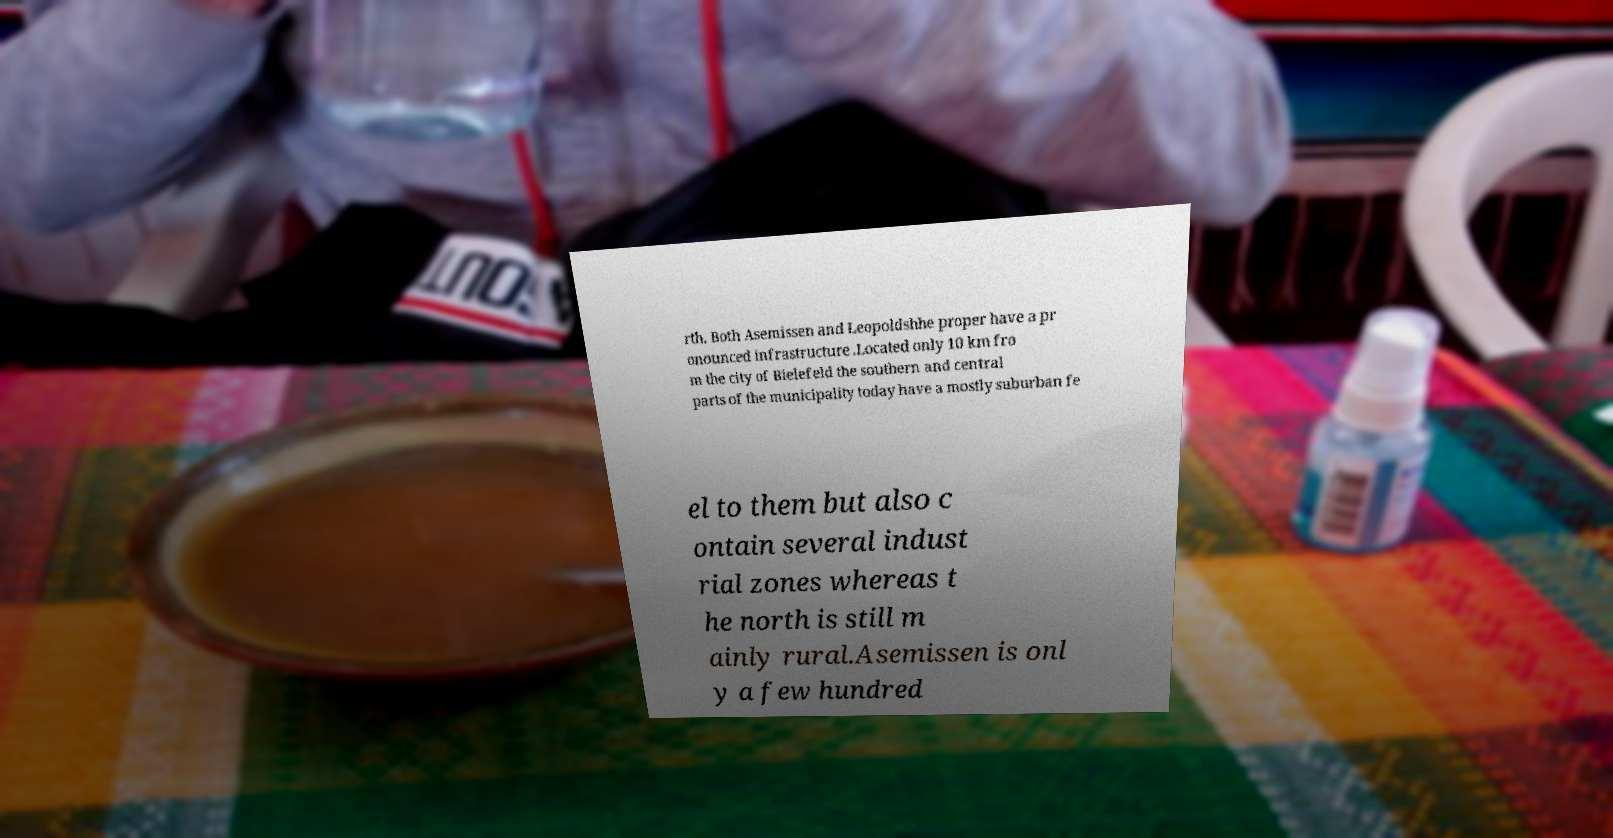Please read and relay the text visible in this image. What does it say? rth. Both Asemissen and Leopoldshhe proper have a pr onounced infrastructure .Located only 10 km fro m the city of Bielefeld the southern and central parts of the municipality today have a mostly suburban fe el to them but also c ontain several indust rial zones whereas t he north is still m ainly rural.Asemissen is onl y a few hundred 